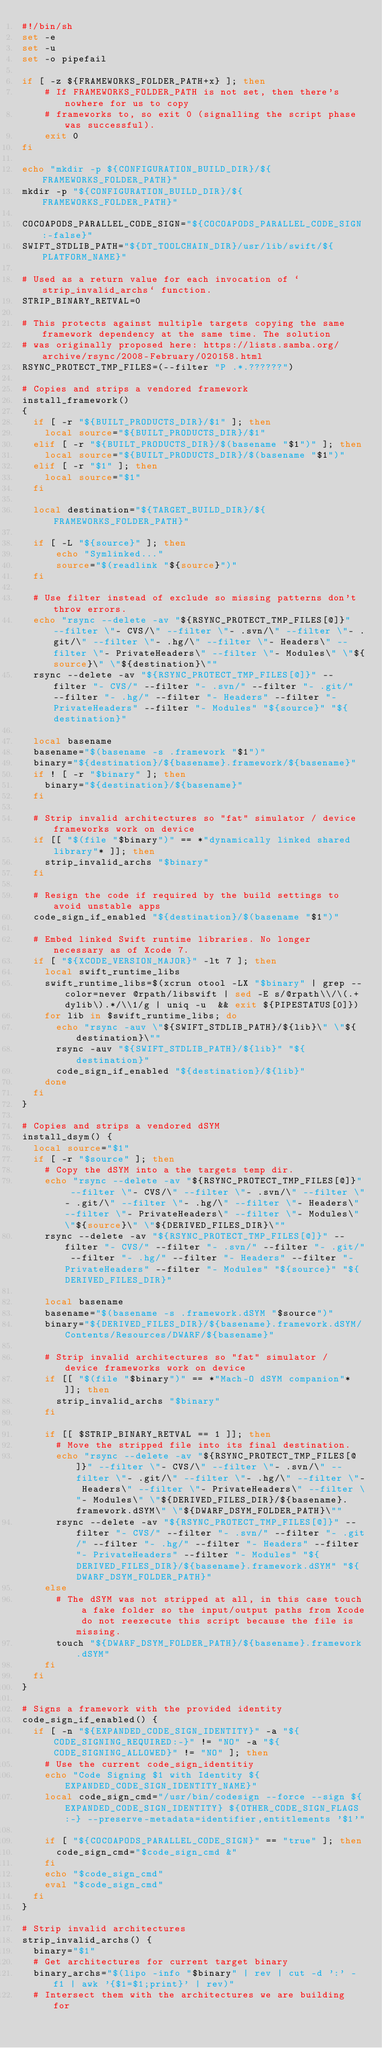Convert code to text. <code><loc_0><loc_0><loc_500><loc_500><_Bash_>#!/bin/sh
set -e
set -u
set -o pipefail

if [ -z ${FRAMEWORKS_FOLDER_PATH+x} ]; then
    # If FRAMEWORKS_FOLDER_PATH is not set, then there's nowhere for us to copy
    # frameworks to, so exit 0 (signalling the script phase was successful).
    exit 0
fi

echo "mkdir -p ${CONFIGURATION_BUILD_DIR}/${FRAMEWORKS_FOLDER_PATH}"
mkdir -p "${CONFIGURATION_BUILD_DIR}/${FRAMEWORKS_FOLDER_PATH}"

COCOAPODS_PARALLEL_CODE_SIGN="${COCOAPODS_PARALLEL_CODE_SIGN:-false}"
SWIFT_STDLIB_PATH="${DT_TOOLCHAIN_DIR}/usr/lib/swift/${PLATFORM_NAME}"

# Used as a return value for each invocation of `strip_invalid_archs` function.
STRIP_BINARY_RETVAL=0

# This protects against multiple targets copying the same framework dependency at the same time. The solution
# was originally proposed here: https://lists.samba.org/archive/rsync/2008-February/020158.html
RSYNC_PROTECT_TMP_FILES=(--filter "P .*.??????")

# Copies and strips a vendored framework
install_framework()
{
  if [ -r "${BUILT_PRODUCTS_DIR}/$1" ]; then
    local source="${BUILT_PRODUCTS_DIR}/$1"
  elif [ -r "${BUILT_PRODUCTS_DIR}/$(basename "$1")" ]; then
    local source="${BUILT_PRODUCTS_DIR}/$(basename "$1")"
  elif [ -r "$1" ]; then
    local source="$1"
  fi

  local destination="${TARGET_BUILD_DIR}/${FRAMEWORKS_FOLDER_PATH}"

  if [ -L "${source}" ]; then
      echo "Symlinked..."
      source="$(readlink "${source}")"
  fi

  # Use filter instead of exclude so missing patterns don't throw errors.
  echo "rsync --delete -av "${RSYNC_PROTECT_TMP_FILES[@]}" --filter \"- CVS/\" --filter \"- .svn/\" --filter \"- .git/\" --filter \"- .hg/\" --filter \"- Headers\" --filter \"- PrivateHeaders\" --filter \"- Modules\" \"${source}\" \"${destination}\""
  rsync --delete -av "${RSYNC_PROTECT_TMP_FILES[@]}" --filter "- CVS/" --filter "- .svn/" --filter "- .git/" --filter "- .hg/" --filter "- Headers" --filter "- PrivateHeaders" --filter "- Modules" "${source}" "${destination}"

  local basename
  basename="$(basename -s .framework "$1")"
  binary="${destination}/${basename}.framework/${basename}"
  if ! [ -r "$binary" ]; then
    binary="${destination}/${basename}"
  fi

  # Strip invalid architectures so "fat" simulator / device frameworks work on device
  if [[ "$(file "$binary")" == *"dynamically linked shared library"* ]]; then
    strip_invalid_archs "$binary"
  fi

  # Resign the code if required by the build settings to avoid unstable apps
  code_sign_if_enabled "${destination}/$(basename "$1")"

  # Embed linked Swift runtime libraries. No longer necessary as of Xcode 7.
  if [ "${XCODE_VERSION_MAJOR}" -lt 7 ]; then
    local swift_runtime_libs
    swift_runtime_libs=$(xcrun otool -LX "$binary" | grep --color=never @rpath/libswift | sed -E s/@rpath\\/\(.+dylib\).*/\\1/g | uniq -u  && exit ${PIPESTATUS[0]})
    for lib in $swift_runtime_libs; do
      echo "rsync -auv \"${SWIFT_STDLIB_PATH}/${lib}\" \"${destination}\""
      rsync -auv "${SWIFT_STDLIB_PATH}/${lib}" "${destination}"
      code_sign_if_enabled "${destination}/${lib}"
    done
  fi
}

# Copies and strips a vendored dSYM
install_dsym() {
  local source="$1"
  if [ -r "$source" ]; then
    # Copy the dSYM into a the targets temp dir.
    echo "rsync --delete -av "${RSYNC_PROTECT_TMP_FILES[@]}" --filter \"- CVS/\" --filter \"- .svn/\" --filter \"- .git/\" --filter \"- .hg/\" --filter \"- Headers\" --filter \"- PrivateHeaders\" --filter \"- Modules\" \"${source}\" \"${DERIVED_FILES_DIR}\""
    rsync --delete -av "${RSYNC_PROTECT_TMP_FILES[@]}" --filter "- CVS/" --filter "- .svn/" --filter "- .git/" --filter "- .hg/" --filter "- Headers" --filter "- PrivateHeaders" --filter "- Modules" "${source}" "${DERIVED_FILES_DIR}"

    local basename
    basename="$(basename -s .framework.dSYM "$source")"
    binary="${DERIVED_FILES_DIR}/${basename}.framework.dSYM/Contents/Resources/DWARF/${basename}"

    # Strip invalid architectures so "fat" simulator / device frameworks work on device
    if [[ "$(file "$binary")" == *"Mach-O dSYM companion"* ]]; then
      strip_invalid_archs "$binary"
    fi

    if [[ $STRIP_BINARY_RETVAL == 1 ]]; then
      # Move the stripped file into its final destination.
      echo "rsync --delete -av "${RSYNC_PROTECT_TMP_FILES[@]}" --filter \"- CVS/\" --filter \"- .svn/\" --filter \"- .git/\" --filter \"- .hg/\" --filter \"- Headers\" --filter \"- PrivateHeaders\" --filter \"- Modules\" \"${DERIVED_FILES_DIR}/${basename}.framework.dSYM\" \"${DWARF_DSYM_FOLDER_PATH}\""
      rsync --delete -av "${RSYNC_PROTECT_TMP_FILES[@]}" --filter "- CVS/" --filter "- .svn/" --filter "- .git/" --filter "- .hg/" --filter "- Headers" --filter "- PrivateHeaders" --filter "- Modules" "${DERIVED_FILES_DIR}/${basename}.framework.dSYM" "${DWARF_DSYM_FOLDER_PATH}"
    else
      # The dSYM was not stripped at all, in this case touch a fake folder so the input/output paths from Xcode do not reexecute this script because the file is missing.
      touch "${DWARF_DSYM_FOLDER_PATH}/${basename}.framework.dSYM"
    fi
  fi
}

# Signs a framework with the provided identity
code_sign_if_enabled() {
  if [ -n "${EXPANDED_CODE_SIGN_IDENTITY}" -a "${CODE_SIGNING_REQUIRED:-}" != "NO" -a "${CODE_SIGNING_ALLOWED}" != "NO" ]; then
    # Use the current code_sign_identitiy
    echo "Code Signing $1 with Identity ${EXPANDED_CODE_SIGN_IDENTITY_NAME}"
    local code_sign_cmd="/usr/bin/codesign --force --sign ${EXPANDED_CODE_SIGN_IDENTITY} ${OTHER_CODE_SIGN_FLAGS:-} --preserve-metadata=identifier,entitlements '$1'"

    if [ "${COCOAPODS_PARALLEL_CODE_SIGN}" == "true" ]; then
      code_sign_cmd="$code_sign_cmd &"
    fi
    echo "$code_sign_cmd"
    eval "$code_sign_cmd"
  fi
}

# Strip invalid architectures
strip_invalid_archs() {
  binary="$1"
  # Get architectures for current target binary
  binary_archs="$(lipo -info "$binary" | rev | cut -d ':' -f1 | awk '{$1=$1;print}' | rev)"
  # Intersect them with the architectures we are building for</code> 